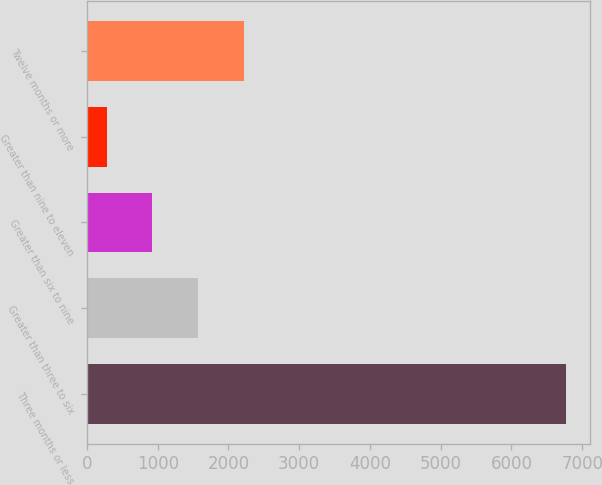<chart> <loc_0><loc_0><loc_500><loc_500><bar_chart><fcel>Three months or less<fcel>Greater than three to six<fcel>Greater than six to nine<fcel>Greater than nine to eleven<fcel>Twelve months or more<nl><fcel>6773<fcel>1575.4<fcel>925.7<fcel>276<fcel>2225.1<nl></chart> 